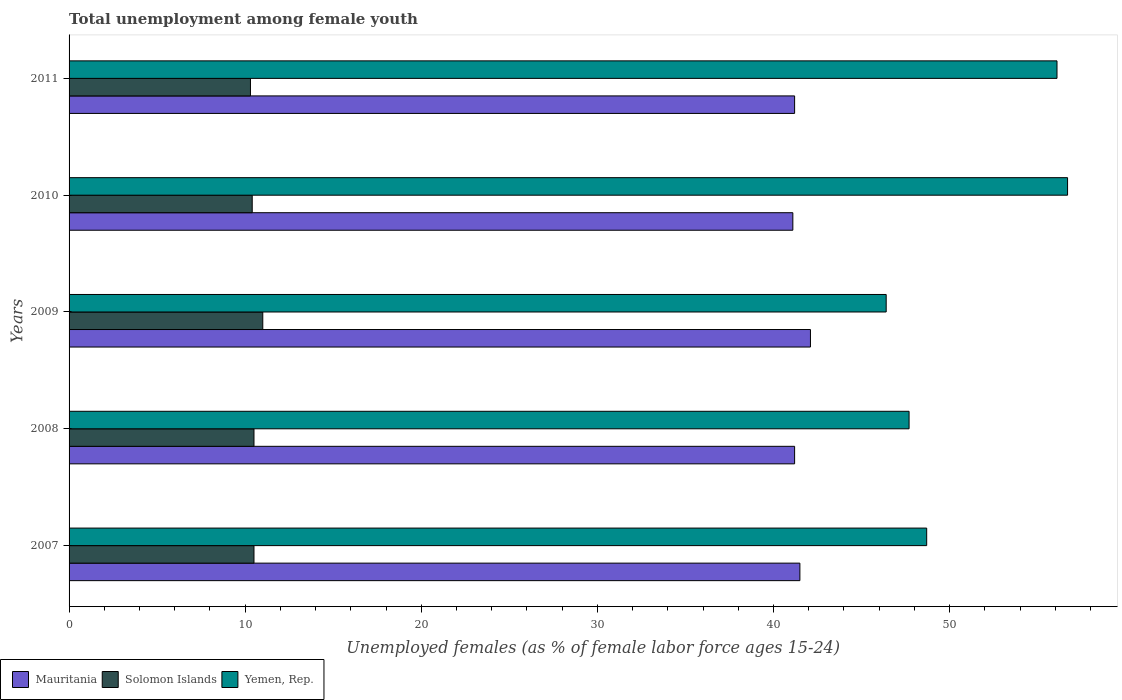How many different coloured bars are there?
Your response must be concise. 3. How many groups of bars are there?
Provide a short and direct response. 5. What is the label of the 5th group of bars from the top?
Make the answer very short. 2007. What is the percentage of unemployed females in in Yemen, Rep. in 2011?
Make the answer very short. 56.1. Across all years, what is the maximum percentage of unemployed females in in Solomon Islands?
Keep it short and to the point. 11. Across all years, what is the minimum percentage of unemployed females in in Solomon Islands?
Ensure brevity in your answer.  10.3. What is the total percentage of unemployed females in in Solomon Islands in the graph?
Provide a succinct answer. 52.7. What is the difference between the percentage of unemployed females in in Mauritania in 2008 and that in 2009?
Your response must be concise. -0.9. What is the difference between the percentage of unemployed females in in Solomon Islands in 2010 and the percentage of unemployed females in in Mauritania in 2009?
Your answer should be compact. -31.7. What is the average percentage of unemployed females in in Solomon Islands per year?
Your response must be concise. 10.54. In how many years, is the percentage of unemployed females in in Solomon Islands greater than 52 %?
Your answer should be very brief. 0. What is the ratio of the percentage of unemployed females in in Mauritania in 2007 to that in 2008?
Your answer should be very brief. 1.01. Is the percentage of unemployed females in in Yemen, Rep. in 2007 less than that in 2010?
Give a very brief answer. Yes. Is the difference between the percentage of unemployed females in in Mauritania in 2008 and 2009 greater than the difference between the percentage of unemployed females in in Yemen, Rep. in 2008 and 2009?
Give a very brief answer. No. What is the difference between the highest and the second highest percentage of unemployed females in in Mauritania?
Keep it short and to the point. 0.6. What is the difference between the highest and the lowest percentage of unemployed females in in Solomon Islands?
Provide a succinct answer. 0.7. In how many years, is the percentage of unemployed females in in Yemen, Rep. greater than the average percentage of unemployed females in in Yemen, Rep. taken over all years?
Your response must be concise. 2. Is the sum of the percentage of unemployed females in in Yemen, Rep. in 2009 and 2010 greater than the maximum percentage of unemployed females in in Solomon Islands across all years?
Provide a short and direct response. Yes. What does the 3rd bar from the top in 2008 represents?
Offer a very short reply. Mauritania. What does the 1st bar from the bottom in 2011 represents?
Provide a succinct answer. Mauritania. How many years are there in the graph?
Give a very brief answer. 5. What is the difference between two consecutive major ticks on the X-axis?
Your response must be concise. 10. Does the graph contain any zero values?
Keep it short and to the point. No. Does the graph contain grids?
Keep it short and to the point. No. Where does the legend appear in the graph?
Offer a terse response. Bottom left. What is the title of the graph?
Make the answer very short. Total unemployment among female youth. Does "United Arab Emirates" appear as one of the legend labels in the graph?
Your response must be concise. No. What is the label or title of the X-axis?
Offer a very short reply. Unemployed females (as % of female labor force ages 15-24). What is the label or title of the Y-axis?
Provide a succinct answer. Years. What is the Unemployed females (as % of female labor force ages 15-24) in Mauritania in 2007?
Give a very brief answer. 41.5. What is the Unemployed females (as % of female labor force ages 15-24) of Yemen, Rep. in 2007?
Provide a succinct answer. 48.7. What is the Unemployed females (as % of female labor force ages 15-24) in Mauritania in 2008?
Make the answer very short. 41.2. What is the Unemployed females (as % of female labor force ages 15-24) in Solomon Islands in 2008?
Ensure brevity in your answer.  10.5. What is the Unemployed females (as % of female labor force ages 15-24) in Yemen, Rep. in 2008?
Your response must be concise. 47.7. What is the Unemployed females (as % of female labor force ages 15-24) of Mauritania in 2009?
Offer a terse response. 42.1. What is the Unemployed females (as % of female labor force ages 15-24) of Solomon Islands in 2009?
Your response must be concise. 11. What is the Unemployed females (as % of female labor force ages 15-24) in Yemen, Rep. in 2009?
Offer a very short reply. 46.4. What is the Unemployed females (as % of female labor force ages 15-24) of Mauritania in 2010?
Your response must be concise. 41.1. What is the Unemployed females (as % of female labor force ages 15-24) of Solomon Islands in 2010?
Offer a very short reply. 10.4. What is the Unemployed females (as % of female labor force ages 15-24) in Yemen, Rep. in 2010?
Offer a very short reply. 56.7. What is the Unemployed females (as % of female labor force ages 15-24) of Mauritania in 2011?
Offer a very short reply. 41.2. What is the Unemployed females (as % of female labor force ages 15-24) in Solomon Islands in 2011?
Your response must be concise. 10.3. What is the Unemployed females (as % of female labor force ages 15-24) in Yemen, Rep. in 2011?
Provide a short and direct response. 56.1. Across all years, what is the maximum Unemployed females (as % of female labor force ages 15-24) of Mauritania?
Offer a very short reply. 42.1. Across all years, what is the maximum Unemployed females (as % of female labor force ages 15-24) in Yemen, Rep.?
Provide a succinct answer. 56.7. Across all years, what is the minimum Unemployed females (as % of female labor force ages 15-24) in Mauritania?
Provide a short and direct response. 41.1. Across all years, what is the minimum Unemployed females (as % of female labor force ages 15-24) in Solomon Islands?
Provide a succinct answer. 10.3. Across all years, what is the minimum Unemployed females (as % of female labor force ages 15-24) in Yemen, Rep.?
Your answer should be very brief. 46.4. What is the total Unemployed females (as % of female labor force ages 15-24) in Mauritania in the graph?
Provide a short and direct response. 207.1. What is the total Unemployed females (as % of female labor force ages 15-24) in Solomon Islands in the graph?
Keep it short and to the point. 52.7. What is the total Unemployed females (as % of female labor force ages 15-24) in Yemen, Rep. in the graph?
Provide a succinct answer. 255.6. What is the difference between the Unemployed females (as % of female labor force ages 15-24) in Solomon Islands in 2007 and that in 2008?
Your answer should be compact. 0. What is the difference between the Unemployed females (as % of female labor force ages 15-24) in Yemen, Rep. in 2007 and that in 2009?
Your response must be concise. 2.3. What is the difference between the Unemployed females (as % of female labor force ages 15-24) of Mauritania in 2008 and that in 2009?
Make the answer very short. -0.9. What is the difference between the Unemployed females (as % of female labor force ages 15-24) in Mauritania in 2008 and that in 2010?
Your answer should be very brief. 0.1. What is the difference between the Unemployed females (as % of female labor force ages 15-24) in Solomon Islands in 2008 and that in 2010?
Keep it short and to the point. 0.1. What is the difference between the Unemployed females (as % of female labor force ages 15-24) in Solomon Islands in 2008 and that in 2011?
Ensure brevity in your answer.  0.2. What is the difference between the Unemployed females (as % of female labor force ages 15-24) in Solomon Islands in 2009 and that in 2010?
Your answer should be compact. 0.6. What is the difference between the Unemployed females (as % of female labor force ages 15-24) in Yemen, Rep. in 2009 and that in 2010?
Your response must be concise. -10.3. What is the difference between the Unemployed females (as % of female labor force ages 15-24) in Mauritania in 2009 and that in 2011?
Make the answer very short. 0.9. What is the difference between the Unemployed females (as % of female labor force ages 15-24) in Mauritania in 2010 and that in 2011?
Your answer should be compact. -0.1. What is the difference between the Unemployed females (as % of female labor force ages 15-24) in Yemen, Rep. in 2010 and that in 2011?
Offer a terse response. 0.6. What is the difference between the Unemployed females (as % of female labor force ages 15-24) in Mauritania in 2007 and the Unemployed females (as % of female labor force ages 15-24) in Yemen, Rep. in 2008?
Provide a succinct answer. -6.2. What is the difference between the Unemployed females (as % of female labor force ages 15-24) of Solomon Islands in 2007 and the Unemployed females (as % of female labor force ages 15-24) of Yemen, Rep. in 2008?
Ensure brevity in your answer.  -37.2. What is the difference between the Unemployed females (as % of female labor force ages 15-24) in Mauritania in 2007 and the Unemployed females (as % of female labor force ages 15-24) in Solomon Islands in 2009?
Your answer should be very brief. 30.5. What is the difference between the Unemployed females (as % of female labor force ages 15-24) in Mauritania in 2007 and the Unemployed females (as % of female labor force ages 15-24) in Yemen, Rep. in 2009?
Give a very brief answer. -4.9. What is the difference between the Unemployed females (as % of female labor force ages 15-24) of Solomon Islands in 2007 and the Unemployed females (as % of female labor force ages 15-24) of Yemen, Rep. in 2009?
Offer a terse response. -35.9. What is the difference between the Unemployed females (as % of female labor force ages 15-24) in Mauritania in 2007 and the Unemployed females (as % of female labor force ages 15-24) in Solomon Islands in 2010?
Your response must be concise. 31.1. What is the difference between the Unemployed females (as % of female labor force ages 15-24) in Mauritania in 2007 and the Unemployed females (as % of female labor force ages 15-24) in Yemen, Rep. in 2010?
Provide a succinct answer. -15.2. What is the difference between the Unemployed females (as % of female labor force ages 15-24) in Solomon Islands in 2007 and the Unemployed females (as % of female labor force ages 15-24) in Yemen, Rep. in 2010?
Give a very brief answer. -46.2. What is the difference between the Unemployed females (as % of female labor force ages 15-24) of Mauritania in 2007 and the Unemployed females (as % of female labor force ages 15-24) of Solomon Islands in 2011?
Your answer should be compact. 31.2. What is the difference between the Unemployed females (as % of female labor force ages 15-24) of Mauritania in 2007 and the Unemployed females (as % of female labor force ages 15-24) of Yemen, Rep. in 2011?
Provide a short and direct response. -14.6. What is the difference between the Unemployed females (as % of female labor force ages 15-24) in Solomon Islands in 2007 and the Unemployed females (as % of female labor force ages 15-24) in Yemen, Rep. in 2011?
Ensure brevity in your answer.  -45.6. What is the difference between the Unemployed females (as % of female labor force ages 15-24) in Mauritania in 2008 and the Unemployed females (as % of female labor force ages 15-24) in Solomon Islands in 2009?
Provide a short and direct response. 30.2. What is the difference between the Unemployed females (as % of female labor force ages 15-24) of Solomon Islands in 2008 and the Unemployed females (as % of female labor force ages 15-24) of Yemen, Rep. in 2009?
Ensure brevity in your answer.  -35.9. What is the difference between the Unemployed females (as % of female labor force ages 15-24) of Mauritania in 2008 and the Unemployed females (as % of female labor force ages 15-24) of Solomon Islands in 2010?
Your response must be concise. 30.8. What is the difference between the Unemployed females (as % of female labor force ages 15-24) in Mauritania in 2008 and the Unemployed females (as % of female labor force ages 15-24) in Yemen, Rep. in 2010?
Your answer should be compact. -15.5. What is the difference between the Unemployed females (as % of female labor force ages 15-24) of Solomon Islands in 2008 and the Unemployed females (as % of female labor force ages 15-24) of Yemen, Rep. in 2010?
Make the answer very short. -46.2. What is the difference between the Unemployed females (as % of female labor force ages 15-24) in Mauritania in 2008 and the Unemployed females (as % of female labor force ages 15-24) in Solomon Islands in 2011?
Give a very brief answer. 30.9. What is the difference between the Unemployed females (as % of female labor force ages 15-24) in Mauritania in 2008 and the Unemployed females (as % of female labor force ages 15-24) in Yemen, Rep. in 2011?
Provide a short and direct response. -14.9. What is the difference between the Unemployed females (as % of female labor force ages 15-24) of Solomon Islands in 2008 and the Unemployed females (as % of female labor force ages 15-24) of Yemen, Rep. in 2011?
Give a very brief answer. -45.6. What is the difference between the Unemployed females (as % of female labor force ages 15-24) in Mauritania in 2009 and the Unemployed females (as % of female labor force ages 15-24) in Solomon Islands in 2010?
Ensure brevity in your answer.  31.7. What is the difference between the Unemployed females (as % of female labor force ages 15-24) of Mauritania in 2009 and the Unemployed females (as % of female labor force ages 15-24) of Yemen, Rep. in 2010?
Keep it short and to the point. -14.6. What is the difference between the Unemployed females (as % of female labor force ages 15-24) in Solomon Islands in 2009 and the Unemployed females (as % of female labor force ages 15-24) in Yemen, Rep. in 2010?
Your answer should be compact. -45.7. What is the difference between the Unemployed females (as % of female labor force ages 15-24) in Mauritania in 2009 and the Unemployed females (as % of female labor force ages 15-24) in Solomon Islands in 2011?
Provide a short and direct response. 31.8. What is the difference between the Unemployed females (as % of female labor force ages 15-24) of Solomon Islands in 2009 and the Unemployed females (as % of female labor force ages 15-24) of Yemen, Rep. in 2011?
Keep it short and to the point. -45.1. What is the difference between the Unemployed females (as % of female labor force ages 15-24) of Mauritania in 2010 and the Unemployed females (as % of female labor force ages 15-24) of Solomon Islands in 2011?
Give a very brief answer. 30.8. What is the difference between the Unemployed females (as % of female labor force ages 15-24) of Solomon Islands in 2010 and the Unemployed females (as % of female labor force ages 15-24) of Yemen, Rep. in 2011?
Your response must be concise. -45.7. What is the average Unemployed females (as % of female labor force ages 15-24) of Mauritania per year?
Provide a succinct answer. 41.42. What is the average Unemployed females (as % of female labor force ages 15-24) in Solomon Islands per year?
Provide a succinct answer. 10.54. What is the average Unemployed females (as % of female labor force ages 15-24) in Yemen, Rep. per year?
Provide a short and direct response. 51.12. In the year 2007, what is the difference between the Unemployed females (as % of female labor force ages 15-24) in Mauritania and Unemployed females (as % of female labor force ages 15-24) in Solomon Islands?
Offer a terse response. 31. In the year 2007, what is the difference between the Unemployed females (as % of female labor force ages 15-24) in Mauritania and Unemployed females (as % of female labor force ages 15-24) in Yemen, Rep.?
Keep it short and to the point. -7.2. In the year 2007, what is the difference between the Unemployed females (as % of female labor force ages 15-24) in Solomon Islands and Unemployed females (as % of female labor force ages 15-24) in Yemen, Rep.?
Provide a succinct answer. -38.2. In the year 2008, what is the difference between the Unemployed females (as % of female labor force ages 15-24) in Mauritania and Unemployed females (as % of female labor force ages 15-24) in Solomon Islands?
Offer a very short reply. 30.7. In the year 2008, what is the difference between the Unemployed females (as % of female labor force ages 15-24) of Solomon Islands and Unemployed females (as % of female labor force ages 15-24) of Yemen, Rep.?
Your response must be concise. -37.2. In the year 2009, what is the difference between the Unemployed females (as % of female labor force ages 15-24) of Mauritania and Unemployed females (as % of female labor force ages 15-24) of Solomon Islands?
Your answer should be compact. 31.1. In the year 2009, what is the difference between the Unemployed females (as % of female labor force ages 15-24) of Mauritania and Unemployed females (as % of female labor force ages 15-24) of Yemen, Rep.?
Offer a very short reply. -4.3. In the year 2009, what is the difference between the Unemployed females (as % of female labor force ages 15-24) of Solomon Islands and Unemployed females (as % of female labor force ages 15-24) of Yemen, Rep.?
Offer a terse response. -35.4. In the year 2010, what is the difference between the Unemployed females (as % of female labor force ages 15-24) in Mauritania and Unemployed females (as % of female labor force ages 15-24) in Solomon Islands?
Provide a succinct answer. 30.7. In the year 2010, what is the difference between the Unemployed females (as % of female labor force ages 15-24) in Mauritania and Unemployed females (as % of female labor force ages 15-24) in Yemen, Rep.?
Ensure brevity in your answer.  -15.6. In the year 2010, what is the difference between the Unemployed females (as % of female labor force ages 15-24) in Solomon Islands and Unemployed females (as % of female labor force ages 15-24) in Yemen, Rep.?
Give a very brief answer. -46.3. In the year 2011, what is the difference between the Unemployed females (as % of female labor force ages 15-24) in Mauritania and Unemployed females (as % of female labor force ages 15-24) in Solomon Islands?
Give a very brief answer. 30.9. In the year 2011, what is the difference between the Unemployed females (as % of female labor force ages 15-24) of Mauritania and Unemployed females (as % of female labor force ages 15-24) of Yemen, Rep.?
Your answer should be very brief. -14.9. In the year 2011, what is the difference between the Unemployed females (as % of female labor force ages 15-24) in Solomon Islands and Unemployed females (as % of female labor force ages 15-24) in Yemen, Rep.?
Provide a succinct answer. -45.8. What is the ratio of the Unemployed females (as % of female labor force ages 15-24) in Mauritania in 2007 to that in 2008?
Give a very brief answer. 1.01. What is the ratio of the Unemployed females (as % of female labor force ages 15-24) of Yemen, Rep. in 2007 to that in 2008?
Keep it short and to the point. 1.02. What is the ratio of the Unemployed females (as % of female labor force ages 15-24) in Mauritania in 2007 to that in 2009?
Keep it short and to the point. 0.99. What is the ratio of the Unemployed females (as % of female labor force ages 15-24) in Solomon Islands in 2007 to that in 2009?
Offer a very short reply. 0.95. What is the ratio of the Unemployed females (as % of female labor force ages 15-24) of Yemen, Rep. in 2007 to that in 2009?
Keep it short and to the point. 1.05. What is the ratio of the Unemployed females (as % of female labor force ages 15-24) of Mauritania in 2007 to that in 2010?
Provide a succinct answer. 1.01. What is the ratio of the Unemployed females (as % of female labor force ages 15-24) of Solomon Islands in 2007 to that in 2010?
Offer a very short reply. 1.01. What is the ratio of the Unemployed females (as % of female labor force ages 15-24) of Yemen, Rep. in 2007 to that in 2010?
Make the answer very short. 0.86. What is the ratio of the Unemployed females (as % of female labor force ages 15-24) of Mauritania in 2007 to that in 2011?
Ensure brevity in your answer.  1.01. What is the ratio of the Unemployed females (as % of female labor force ages 15-24) in Solomon Islands in 2007 to that in 2011?
Make the answer very short. 1.02. What is the ratio of the Unemployed females (as % of female labor force ages 15-24) in Yemen, Rep. in 2007 to that in 2011?
Provide a succinct answer. 0.87. What is the ratio of the Unemployed females (as % of female labor force ages 15-24) in Mauritania in 2008 to that in 2009?
Provide a succinct answer. 0.98. What is the ratio of the Unemployed females (as % of female labor force ages 15-24) in Solomon Islands in 2008 to that in 2009?
Give a very brief answer. 0.95. What is the ratio of the Unemployed females (as % of female labor force ages 15-24) of Yemen, Rep. in 2008 to that in 2009?
Your answer should be very brief. 1.03. What is the ratio of the Unemployed females (as % of female labor force ages 15-24) of Solomon Islands in 2008 to that in 2010?
Provide a succinct answer. 1.01. What is the ratio of the Unemployed females (as % of female labor force ages 15-24) of Yemen, Rep. in 2008 to that in 2010?
Make the answer very short. 0.84. What is the ratio of the Unemployed females (as % of female labor force ages 15-24) of Mauritania in 2008 to that in 2011?
Your answer should be very brief. 1. What is the ratio of the Unemployed females (as % of female labor force ages 15-24) of Solomon Islands in 2008 to that in 2011?
Your answer should be very brief. 1.02. What is the ratio of the Unemployed females (as % of female labor force ages 15-24) in Yemen, Rep. in 2008 to that in 2011?
Offer a very short reply. 0.85. What is the ratio of the Unemployed females (as % of female labor force ages 15-24) in Mauritania in 2009 to that in 2010?
Ensure brevity in your answer.  1.02. What is the ratio of the Unemployed females (as % of female labor force ages 15-24) of Solomon Islands in 2009 to that in 2010?
Provide a short and direct response. 1.06. What is the ratio of the Unemployed females (as % of female labor force ages 15-24) in Yemen, Rep. in 2009 to that in 2010?
Offer a very short reply. 0.82. What is the ratio of the Unemployed females (as % of female labor force ages 15-24) in Mauritania in 2009 to that in 2011?
Give a very brief answer. 1.02. What is the ratio of the Unemployed females (as % of female labor force ages 15-24) in Solomon Islands in 2009 to that in 2011?
Offer a very short reply. 1.07. What is the ratio of the Unemployed females (as % of female labor force ages 15-24) in Yemen, Rep. in 2009 to that in 2011?
Provide a succinct answer. 0.83. What is the ratio of the Unemployed females (as % of female labor force ages 15-24) in Mauritania in 2010 to that in 2011?
Give a very brief answer. 1. What is the ratio of the Unemployed females (as % of female labor force ages 15-24) in Solomon Islands in 2010 to that in 2011?
Provide a short and direct response. 1.01. What is the ratio of the Unemployed females (as % of female labor force ages 15-24) in Yemen, Rep. in 2010 to that in 2011?
Your answer should be compact. 1.01. What is the difference between the highest and the second highest Unemployed females (as % of female labor force ages 15-24) in Solomon Islands?
Your answer should be very brief. 0.5. What is the difference between the highest and the lowest Unemployed females (as % of female labor force ages 15-24) in Solomon Islands?
Offer a very short reply. 0.7. 